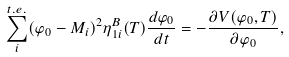Convert formula to latex. <formula><loc_0><loc_0><loc_500><loc_500>\sum _ { i } ^ { t . e . } ( \varphi _ { 0 } - M _ { i } ) ^ { 2 } \eta _ { 1 i } ^ { B } ( T ) \frac { d \varphi _ { 0 } } { d t } = - \frac { \partial V ( \varphi _ { 0 } , T ) } { \partial \varphi _ { 0 } } ,</formula> 